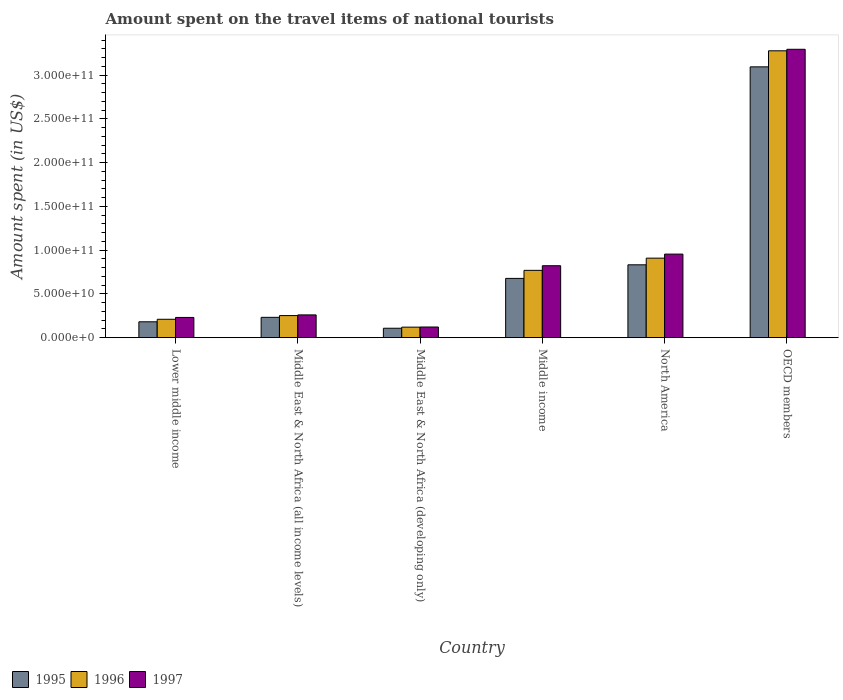How many groups of bars are there?
Give a very brief answer. 6. How many bars are there on the 3rd tick from the left?
Offer a very short reply. 3. What is the label of the 4th group of bars from the left?
Give a very brief answer. Middle income. What is the amount spent on the travel items of national tourists in 1997 in North America?
Ensure brevity in your answer.  9.55e+1. Across all countries, what is the maximum amount spent on the travel items of national tourists in 1997?
Keep it short and to the point. 3.29e+11. Across all countries, what is the minimum amount spent on the travel items of national tourists in 1996?
Offer a terse response. 1.20e+1. In which country was the amount spent on the travel items of national tourists in 1996 minimum?
Make the answer very short. Middle East & North Africa (developing only). What is the total amount spent on the travel items of national tourists in 1997 in the graph?
Your answer should be compact. 5.68e+11. What is the difference between the amount spent on the travel items of national tourists in 1996 in Lower middle income and that in Middle East & North Africa (developing only)?
Your answer should be very brief. 9.01e+09. What is the difference between the amount spent on the travel items of national tourists in 1995 in Lower middle income and the amount spent on the travel items of national tourists in 1996 in Middle East & North Africa (developing only)?
Ensure brevity in your answer.  6.13e+09. What is the average amount spent on the travel items of national tourists in 1995 per country?
Your answer should be very brief. 8.54e+1. What is the difference between the amount spent on the travel items of national tourists of/in 1995 and amount spent on the travel items of national tourists of/in 1996 in Middle East & North Africa (all income levels)?
Give a very brief answer. -1.99e+09. In how many countries, is the amount spent on the travel items of national tourists in 1995 greater than 130000000000 US$?
Offer a very short reply. 1. What is the ratio of the amount spent on the travel items of national tourists in 1995 in Middle East & North Africa (all income levels) to that in Middle income?
Offer a terse response. 0.34. Is the amount spent on the travel items of national tourists in 1997 in Lower middle income less than that in Middle East & North Africa (all income levels)?
Keep it short and to the point. Yes. Is the difference between the amount spent on the travel items of national tourists in 1995 in Middle East & North Africa (all income levels) and North America greater than the difference between the amount spent on the travel items of national tourists in 1996 in Middle East & North Africa (all income levels) and North America?
Your response must be concise. Yes. What is the difference between the highest and the second highest amount spent on the travel items of national tourists in 1996?
Your response must be concise. 2.51e+11. What is the difference between the highest and the lowest amount spent on the travel items of national tourists in 1996?
Your answer should be very brief. 3.16e+11. Is the sum of the amount spent on the travel items of national tourists in 1995 in Middle East & North Africa (all income levels) and OECD members greater than the maximum amount spent on the travel items of national tourists in 1996 across all countries?
Your answer should be compact. Yes. What does the 3rd bar from the left in OECD members represents?
Offer a terse response. 1997. What does the 3rd bar from the right in North America represents?
Your response must be concise. 1995. Are the values on the major ticks of Y-axis written in scientific E-notation?
Your response must be concise. Yes. What is the title of the graph?
Offer a terse response. Amount spent on the travel items of national tourists. Does "1978" appear as one of the legend labels in the graph?
Your response must be concise. No. What is the label or title of the X-axis?
Offer a very short reply. Country. What is the label or title of the Y-axis?
Your response must be concise. Amount spent (in US$). What is the Amount spent (in US$) of 1995 in Lower middle income?
Provide a short and direct response. 1.81e+1. What is the Amount spent (in US$) in 1996 in Lower middle income?
Your response must be concise. 2.10e+1. What is the Amount spent (in US$) in 1997 in Lower middle income?
Ensure brevity in your answer.  2.31e+1. What is the Amount spent (in US$) of 1995 in Middle East & North Africa (all income levels)?
Your response must be concise. 2.32e+1. What is the Amount spent (in US$) in 1996 in Middle East & North Africa (all income levels)?
Keep it short and to the point. 2.52e+1. What is the Amount spent (in US$) of 1997 in Middle East & North Africa (all income levels)?
Your answer should be very brief. 2.60e+1. What is the Amount spent (in US$) of 1995 in Middle East & North Africa (developing only)?
Make the answer very short. 1.08e+1. What is the Amount spent (in US$) in 1996 in Middle East & North Africa (developing only)?
Ensure brevity in your answer.  1.20e+1. What is the Amount spent (in US$) of 1997 in Middle East & North Africa (developing only)?
Your response must be concise. 1.22e+1. What is the Amount spent (in US$) of 1995 in Middle income?
Provide a short and direct response. 6.77e+1. What is the Amount spent (in US$) of 1996 in Middle income?
Your response must be concise. 7.69e+1. What is the Amount spent (in US$) in 1997 in Middle income?
Your response must be concise. 8.22e+1. What is the Amount spent (in US$) in 1995 in North America?
Give a very brief answer. 8.32e+1. What is the Amount spent (in US$) in 1996 in North America?
Keep it short and to the point. 9.09e+1. What is the Amount spent (in US$) of 1997 in North America?
Offer a terse response. 9.55e+1. What is the Amount spent (in US$) in 1995 in OECD members?
Your answer should be very brief. 3.09e+11. What is the Amount spent (in US$) in 1996 in OECD members?
Make the answer very short. 3.28e+11. What is the Amount spent (in US$) in 1997 in OECD members?
Offer a very short reply. 3.29e+11. Across all countries, what is the maximum Amount spent (in US$) in 1995?
Your answer should be compact. 3.09e+11. Across all countries, what is the maximum Amount spent (in US$) in 1996?
Keep it short and to the point. 3.28e+11. Across all countries, what is the maximum Amount spent (in US$) in 1997?
Your answer should be compact. 3.29e+11. Across all countries, what is the minimum Amount spent (in US$) in 1995?
Your answer should be very brief. 1.08e+1. Across all countries, what is the minimum Amount spent (in US$) in 1996?
Your answer should be compact. 1.20e+1. Across all countries, what is the minimum Amount spent (in US$) of 1997?
Keep it short and to the point. 1.22e+1. What is the total Amount spent (in US$) of 1995 in the graph?
Ensure brevity in your answer.  5.13e+11. What is the total Amount spent (in US$) of 1996 in the graph?
Offer a very short reply. 5.54e+11. What is the total Amount spent (in US$) of 1997 in the graph?
Keep it short and to the point. 5.68e+11. What is the difference between the Amount spent (in US$) of 1995 in Lower middle income and that in Middle East & North Africa (all income levels)?
Give a very brief answer. -5.09e+09. What is the difference between the Amount spent (in US$) in 1996 in Lower middle income and that in Middle East & North Africa (all income levels)?
Keep it short and to the point. -4.20e+09. What is the difference between the Amount spent (in US$) of 1997 in Lower middle income and that in Middle East & North Africa (all income levels)?
Offer a terse response. -2.91e+09. What is the difference between the Amount spent (in US$) of 1995 in Lower middle income and that in Middle East & North Africa (developing only)?
Your answer should be compact. 7.36e+09. What is the difference between the Amount spent (in US$) in 1996 in Lower middle income and that in Middle East & North Africa (developing only)?
Provide a succinct answer. 9.01e+09. What is the difference between the Amount spent (in US$) of 1997 in Lower middle income and that in Middle East & North Africa (developing only)?
Ensure brevity in your answer.  1.09e+1. What is the difference between the Amount spent (in US$) of 1995 in Lower middle income and that in Middle income?
Offer a terse response. -4.96e+1. What is the difference between the Amount spent (in US$) of 1996 in Lower middle income and that in Middle income?
Your answer should be very brief. -5.59e+1. What is the difference between the Amount spent (in US$) of 1997 in Lower middle income and that in Middle income?
Offer a terse response. -5.91e+1. What is the difference between the Amount spent (in US$) in 1995 in Lower middle income and that in North America?
Offer a terse response. -6.51e+1. What is the difference between the Amount spent (in US$) of 1996 in Lower middle income and that in North America?
Offer a very short reply. -6.98e+1. What is the difference between the Amount spent (in US$) in 1997 in Lower middle income and that in North America?
Make the answer very short. -7.24e+1. What is the difference between the Amount spent (in US$) of 1995 in Lower middle income and that in OECD members?
Give a very brief answer. -2.91e+11. What is the difference between the Amount spent (in US$) in 1996 in Lower middle income and that in OECD members?
Make the answer very short. -3.07e+11. What is the difference between the Amount spent (in US$) in 1997 in Lower middle income and that in OECD members?
Keep it short and to the point. -3.06e+11. What is the difference between the Amount spent (in US$) of 1995 in Middle East & North Africa (all income levels) and that in Middle East & North Africa (developing only)?
Your response must be concise. 1.25e+1. What is the difference between the Amount spent (in US$) in 1996 in Middle East & North Africa (all income levels) and that in Middle East & North Africa (developing only)?
Make the answer very short. 1.32e+1. What is the difference between the Amount spent (in US$) of 1997 in Middle East & North Africa (all income levels) and that in Middle East & North Africa (developing only)?
Ensure brevity in your answer.  1.38e+1. What is the difference between the Amount spent (in US$) in 1995 in Middle East & North Africa (all income levels) and that in Middle income?
Ensure brevity in your answer.  -4.45e+1. What is the difference between the Amount spent (in US$) of 1996 in Middle East & North Africa (all income levels) and that in Middle income?
Your answer should be very brief. -5.17e+1. What is the difference between the Amount spent (in US$) of 1997 in Middle East & North Africa (all income levels) and that in Middle income?
Provide a short and direct response. -5.62e+1. What is the difference between the Amount spent (in US$) of 1995 in Middle East & North Africa (all income levels) and that in North America?
Offer a very short reply. -6.00e+1. What is the difference between the Amount spent (in US$) in 1996 in Middle East & North Africa (all income levels) and that in North America?
Provide a short and direct response. -6.56e+1. What is the difference between the Amount spent (in US$) in 1997 in Middle East & North Africa (all income levels) and that in North America?
Provide a succinct answer. -6.95e+1. What is the difference between the Amount spent (in US$) of 1995 in Middle East & North Africa (all income levels) and that in OECD members?
Offer a very short reply. -2.86e+11. What is the difference between the Amount spent (in US$) of 1996 in Middle East & North Africa (all income levels) and that in OECD members?
Ensure brevity in your answer.  -3.03e+11. What is the difference between the Amount spent (in US$) of 1997 in Middle East & North Africa (all income levels) and that in OECD members?
Provide a succinct answer. -3.03e+11. What is the difference between the Amount spent (in US$) in 1995 in Middle East & North Africa (developing only) and that in Middle income?
Make the answer very short. -5.69e+1. What is the difference between the Amount spent (in US$) in 1996 in Middle East & North Africa (developing only) and that in Middle income?
Your response must be concise. -6.49e+1. What is the difference between the Amount spent (in US$) in 1997 in Middle East & North Africa (developing only) and that in Middle income?
Make the answer very short. -7.00e+1. What is the difference between the Amount spent (in US$) in 1995 in Middle East & North Africa (developing only) and that in North America?
Keep it short and to the point. -7.25e+1. What is the difference between the Amount spent (in US$) of 1996 in Middle East & North Africa (developing only) and that in North America?
Provide a short and direct response. -7.88e+1. What is the difference between the Amount spent (in US$) of 1997 in Middle East & North Africa (developing only) and that in North America?
Offer a terse response. -8.33e+1. What is the difference between the Amount spent (in US$) in 1995 in Middle East & North Africa (developing only) and that in OECD members?
Keep it short and to the point. -2.99e+11. What is the difference between the Amount spent (in US$) of 1996 in Middle East & North Africa (developing only) and that in OECD members?
Provide a short and direct response. -3.16e+11. What is the difference between the Amount spent (in US$) in 1997 in Middle East & North Africa (developing only) and that in OECD members?
Offer a terse response. -3.17e+11. What is the difference between the Amount spent (in US$) of 1995 in Middle income and that in North America?
Your answer should be very brief. -1.55e+1. What is the difference between the Amount spent (in US$) in 1996 in Middle income and that in North America?
Provide a short and direct response. -1.39e+1. What is the difference between the Amount spent (in US$) in 1997 in Middle income and that in North America?
Provide a succinct answer. -1.33e+1. What is the difference between the Amount spent (in US$) in 1995 in Middle income and that in OECD members?
Ensure brevity in your answer.  -2.42e+11. What is the difference between the Amount spent (in US$) in 1996 in Middle income and that in OECD members?
Your answer should be compact. -2.51e+11. What is the difference between the Amount spent (in US$) of 1997 in Middle income and that in OECD members?
Give a very brief answer. -2.47e+11. What is the difference between the Amount spent (in US$) in 1995 in North America and that in OECD members?
Offer a very short reply. -2.26e+11. What is the difference between the Amount spent (in US$) of 1996 in North America and that in OECD members?
Your answer should be very brief. -2.37e+11. What is the difference between the Amount spent (in US$) of 1997 in North America and that in OECD members?
Offer a terse response. -2.34e+11. What is the difference between the Amount spent (in US$) in 1995 in Lower middle income and the Amount spent (in US$) in 1996 in Middle East & North Africa (all income levels)?
Provide a short and direct response. -7.08e+09. What is the difference between the Amount spent (in US$) in 1995 in Lower middle income and the Amount spent (in US$) in 1997 in Middle East & North Africa (all income levels)?
Make the answer very short. -7.88e+09. What is the difference between the Amount spent (in US$) of 1996 in Lower middle income and the Amount spent (in US$) of 1997 in Middle East & North Africa (all income levels)?
Ensure brevity in your answer.  -5.00e+09. What is the difference between the Amount spent (in US$) of 1995 in Lower middle income and the Amount spent (in US$) of 1996 in Middle East & North Africa (developing only)?
Your answer should be compact. 6.13e+09. What is the difference between the Amount spent (in US$) in 1995 in Lower middle income and the Amount spent (in US$) in 1997 in Middle East & North Africa (developing only)?
Provide a short and direct response. 5.97e+09. What is the difference between the Amount spent (in US$) in 1996 in Lower middle income and the Amount spent (in US$) in 1997 in Middle East & North Africa (developing only)?
Keep it short and to the point. 8.84e+09. What is the difference between the Amount spent (in US$) in 1995 in Lower middle income and the Amount spent (in US$) in 1996 in Middle income?
Give a very brief answer. -5.88e+1. What is the difference between the Amount spent (in US$) of 1995 in Lower middle income and the Amount spent (in US$) of 1997 in Middle income?
Your response must be concise. -6.41e+1. What is the difference between the Amount spent (in US$) of 1996 in Lower middle income and the Amount spent (in US$) of 1997 in Middle income?
Make the answer very short. -6.12e+1. What is the difference between the Amount spent (in US$) of 1995 in Lower middle income and the Amount spent (in US$) of 1996 in North America?
Offer a very short reply. -7.27e+1. What is the difference between the Amount spent (in US$) in 1995 in Lower middle income and the Amount spent (in US$) in 1997 in North America?
Make the answer very short. -7.73e+1. What is the difference between the Amount spent (in US$) in 1996 in Lower middle income and the Amount spent (in US$) in 1997 in North America?
Your answer should be very brief. -7.45e+1. What is the difference between the Amount spent (in US$) of 1995 in Lower middle income and the Amount spent (in US$) of 1996 in OECD members?
Give a very brief answer. -3.10e+11. What is the difference between the Amount spent (in US$) of 1995 in Lower middle income and the Amount spent (in US$) of 1997 in OECD members?
Your response must be concise. -3.11e+11. What is the difference between the Amount spent (in US$) of 1996 in Lower middle income and the Amount spent (in US$) of 1997 in OECD members?
Provide a short and direct response. -3.08e+11. What is the difference between the Amount spent (in US$) of 1995 in Middle East & North Africa (all income levels) and the Amount spent (in US$) of 1996 in Middle East & North Africa (developing only)?
Your response must be concise. 1.12e+1. What is the difference between the Amount spent (in US$) in 1995 in Middle East & North Africa (all income levels) and the Amount spent (in US$) in 1997 in Middle East & North Africa (developing only)?
Make the answer very short. 1.11e+1. What is the difference between the Amount spent (in US$) in 1996 in Middle East & North Africa (all income levels) and the Amount spent (in US$) in 1997 in Middle East & North Africa (developing only)?
Your response must be concise. 1.30e+1. What is the difference between the Amount spent (in US$) in 1995 in Middle East & North Africa (all income levels) and the Amount spent (in US$) in 1996 in Middle income?
Offer a very short reply. -5.37e+1. What is the difference between the Amount spent (in US$) of 1995 in Middle East & North Africa (all income levels) and the Amount spent (in US$) of 1997 in Middle income?
Keep it short and to the point. -5.90e+1. What is the difference between the Amount spent (in US$) in 1996 in Middle East & North Africa (all income levels) and the Amount spent (in US$) in 1997 in Middle income?
Offer a very short reply. -5.70e+1. What is the difference between the Amount spent (in US$) of 1995 in Middle East & North Africa (all income levels) and the Amount spent (in US$) of 1996 in North America?
Offer a very short reply. -6.76e+1. What is the difference between the Amount spent (in US$) of 1995 in Middle East & North Africa (all income levels) and the Amount spent (in US$) of 1997 in North America?
Keep it short and to the point. -7.22e+1. What is the difference between the Amount spent (in US$) of 1996 in Middle East & North Africa (all income levels) and the Amount spent (in US$) of 1997 in North America?
Your answer should be very brief. -7.03e+1. What is the difference between the Amount spent (in US$) in 1995 in Middle East & North Africa (all income levels) and the Amount spent (in US$) in 1996 in OECD members?
Give a very brief answer. -3.05e+11. What is the difference between the Amount spent (in US$) in 1995 in Middle East & North Africa (all income levels) and the Amount spent (in US$) in 1997 in OECD members?
Your answer should be compact. -3.06e+11. What is the difference between the Amount spent (in US$) in 1996 in Middle East & North Africa (all income levels) and the Amount spent (in US$) in 1997 in OECD members?
Offer a terse response. -3.04e+11. What is the difference between the Amount spent (in US$) in 1995 in Middle East & North Africa (developing only) and the Amount spent (in US$) in 1996 in Middle income?
Provide a succinct answer. -6.61e+1. What is the difference between the Amount spent (in US$) in 1995 in Middle East & North Africa (developing only) and the Amount spent (in US$) in 1997 in Middle income?
Provide a short and direct response. -7.14e+1. What is the difference between the Amount spent (in US$) in 1996 in Middle East & North Africa (developing only) and the Amount spent (in US$) in 1997 in Middle income?
Your answer should be very brief. -7.02e+1. What is the difference between the Amount spent (in US$) in 1995 in Middle East & North Africa (developing only) and the Amount spent (in US$) in 1996 in North America?
Ensure brevity in your answer.  -8.01e+1. What is the difference between the Amount spent (in US$) of 1995 in Middle East & North Africa (developing only) and the Amount spent (in US$) of 1997 in North America?
Give a very brief answer. -8.47e+1. What is the difference between the Amount spent (in US$) of 1996 in Middle East & North Africa (developing only) and the Amount spent (in US$) of 1997 in North America?
Offer a very short reply. -8.35e+1. What is the difference between the Amount spent (in US$) of 1995 in Middle East & North Africa (developing only) and the Amount spent (in US$) of 1996 in OECD members?
Make the answer very short. -3.17e+11. What is the difference between the Amount spent (in US$) of 1995 in Middle East & North Africa (developing only) and the Amount spent (in US$) of 1997 in OECD members?
Offer a very short reply. -3.19e+11. What is the difference between the Amount spent (in US$) in 1996 in Middle East & North Africa (developing only) and the Amount spent (in US$) in 1997 in OECD members?
Offer a terse response. -3.17e+11. What is the difference between the Amount spent (in US$) in 1995 in Middle income and the Amount spent (in US$) in 1996 in North America?
Your answer should be very brief. -2.31e+1. What is the difference between the Amount spent (in US$) of 1995 in Middle income and the Amount spent (in US$) of 1997 in North America?
Offer a terse response. -2.78e+1. What is the difference between the Amount spent (in US$) in 1996 in Middle income and the Amount spent (in US$) in 1997 in North America?
Give a very brief answer. -1.86e+1. What is the difference between the Amount spent (in US$) in 1995 in Middle income and the Amount spent (in US$) in 1996 in OECD members?
Ensure brevity in your answer.  -2.60e+11. What is the difference between the Amount spent (in US$) of 1995 in Middle income and the Amount spent (in US$) of 1997 in OECD members?
Your response must be concise. -2.62e+11. What is the difference between the Amount spent (in US$) in 1996 in Middle income and the Amount spent (in US$) in 1997 in OECD members?
Your answer should be very brief. -2.53e+11. What is the difference between the Amount spent (in US$) in 1995 in North America and the Amount spent (in US$) in 1996 in OECD members?
Keep it short and to the point. -2.45e+11. What is the difference between the Amount spent (in US$) of 1995 in North America and the Amount spent (in US$) of 1997 in OECD members?
Your answer should be compact. -2.46e+11. What is the difference between the Amount spent (in US$) of 1996 in North America and the Amount spent (in US$) of 1997 in OECD members?
Offer a very short reply. -2.39e+11. What is the average Amount spent (in US$) of 1995 per country?
Ensure brevity in your answer.  8.54e+1. What is the average Amount spent (in US$) of 1996 per country?
Your answer should be compact. 9.23e+1. What is the average Amount spent (in US$) of 1997 per country?
Provide a short and direct response. 9.47e+1. What is the difference between the Amount spent (in US$) in 1995 and Amount spent (in US$) in 1996 in Lower middle income?
Provide a short and direct response. -2.88e+09. What is the difference between the Amount spent (in US$) of 1995 and Amount spent (in US$) of 1997 in Lower middle income?
Your answer should be very brief. -4.97e+09. What is the difference between the Amount spent (in US$) in 1996 and Amount spent (in US$) in 1997 in Lower middle income?
Provide a short and direct response. -2.09e+09. What is the difference between the Amount spent (in US$) of 1995 and Amount spent (in US$) of 1996 in Middle East & North Africa (all income levels)?
Your response must be concise. -1.99e+09. What is the difference between the Amount spent (in US$) of 1995 and Amount spent (in US$) of 1997 in Middle East & North Africa (all income levels)?
Provide a short and direct response. -2.79e+09. What is the difference between the Amount spent (in US$) in 1996 and Amount spent (in US$) in 1997 in Middle East & North Africa (all income levels)?
Provide a succinct answer. -7.97e+08. What is the difference between the Amount spent (in US$) of 1995 and Amount spent (in US$) of 1996 in Middle East & North Africa (developing only)?
Give a very brief answer. -1.24e+09. What is the difference between the Amount spent (in US$) of 1995 and Amount spent (in US$) of 1997 in Middle East & North Africa (developing only)?
Your response must be concise. -1.40e+09. What is the difference between the Amount spent (in US$) in 1996 and Amount spent (in US$) in 1997 in Middle East & North Africa (developing only)?
Ensure brevity in your answer.  -1.61e+08. What is the difference between the Amount spent (in US$) of 1995 and Amount spent (in US$) of 1996 in Middle income?
Offer a terse response. -9.19e+09. What is the difference between the Amount spent (in US$) in 1995 and Amount spent (in US$) in 1997 in Middle income?
Make the answer very short. -1.45e+1. What is the difference between the Amount spent (in US$) in 1996 and Amount spent (in US$) in 1997 in Middle income?
Provide a short and direct response. -5.28e+09. What is the difference between the Amount spent (in US$) in 1995 and Amount spent (in US$) in 1996 in North America?
Provide a short and direct response. -7.61e+09. What is the difference between the Amount spent (in US$) in 1995 and Amount spent (in US$) in 1997 in North America?
Your answer should be very brief. -1.22e+1. What is the difference between the Amount spent (in US$) in 1996 and Amount spent (in US$) in 1997 in North America?
Make the answer very short. -4.62e+09. What is the difference between the Amount spent (in US$) of 1995 and Amount spent (in US$) of 1996 in OECD members?
Keep it short and to the point. -1.83e+1. What is the difference between the Amount spent (in US$) in 1995 and Amount spent (in US$) in 1997 in OECD members?
Keep it short and to the point. -2.01e+1. What is the difference between the Amount spent (in US$) in 1996 and Amount spent (in US$) in 1997 in OECD members?
Ensure brevity in your answer.  -1.72e+09. What is the ratio of the Amount spent (in US$) in 1995 in Lower middle income to that in Middle East & North Africa (all income levels)?
Your response must be concise. 0.78. What is the ratio of the Amount spent (in US$) in 1996 in Lower middle income to that in Middle East & North Africa (all income levels)?
Give a very brief answer. 0.83. What is the ratio of the Amount spent (in US$) in 1997 in Lower middle income to that in Middle East & North Africa (all income levels)?
Offer a very short reply. 0.89. What is the ratio of the Amount spent (in US$) in 1995 in Lower middle income to that in Middle East & North Africa (developing only)?
Provide a short and direct response. 1.68. What is the ratio of the Amount spent (in US$) of 1996 in Lower middle income to that in Middle East & North Africa (developing only)?
Your answer should be compact. 1.75. What is the ratio of the Amount spent (in US$) of 1997 in Lower middle income to that in Middle East & North Africa (developing only)?
Offer a very short reply. 1.9. What is the ratio of the Amount spent (in US$) in 1995 in Lower middle income to that in Middle income?
Provide a short and direct response. 0.27. What is the ratio of the Amount spent (in US$) of 1996 in Lower middle income to that in Middle income?
Provide a succinct answer. 0.27. What is the ratio of the Amount spent (in US$) of 1997 in Lower middle income to that in Middle income?
Offer a terse response. 0.28. What is the ratio of the Amount spent (in US$) in 1995 in Lower middle income to that in North America?
Your answer should be compact. 0.22. What is the ratio of the Amount spent (in US$) of 1996 in Lower middle income to that in North America?
Make the answer very short. 0.23. What is the ratio of the Amount spent (in US$) of 1997 in Lower middle income to that in North America?
Provide a succinct answer. 0.24. What is the ratio of the Amount spent (in US$) of 1995 in Lower middle income to that in OECD members?
Your answer should be very brief. 0.06. What is the ratio of the Amount spent (in US$) in 1996 in Lower middle income to that in OECD members?
Keep it short and to the point. 0.06. What is the ratio of the Amount spent (in US$) of 1997 in Lower middle income to that in OECD members?
Make the answer very short. 0.07. What is the ratio of the Amount spent (in US$) in 1995 in Middle East & North Africa (all income levels) to that in Middle East & North Africa (developing only)?
Keep it short and to the point. 2.16. What is the ratio of the Amount spent (in US$) in 1996 in Middle East & North Africa (all income levels) to that in Middle East & North Africa (developing only)?
Offer a terse response. 2.1. What is the ratio of the Amount spent (in US$) of 1997 in Middle East & North Africa (all income levels) to that in Middle East & North Africa (developing only)?
Keep it short and to the point. 2.14. What is the ratio of the Amount spent (in US$) of 1995 in Middle East & North Africa (all income levels) to that in Middle income?
Provide a succinct answer. 0.34. What is the ratio of the Amount spent (in US$) of 1996 in Middle East & North Africa (all income levels) to that in Middle income?
Give a very brief answer. 0.33. What is the ratio of the Amount spent (in US$) in 1997 in Middle East & North Africa (all income levels) to that in Middle income?
Provide a succinct answer. 0.32. What is the ratio of the Amount spent (in US$) in 1995 in Middle East & North Africa (all income levels) to that in North America?
Your response must be concise. 0.28. What is the ratio of the Amount spent (in US$) of 1996 in Middle East & North Africa (all income levels) to that in North America?
Offer a terse response. 0.28. What is the ratio of the Amount spent (in US$) of 1997 in Middle East & North Africa (all income levels) to that in North America?
Give a very brief answer. 0.27. What is the ratio of the Amount spent (in US$) of 1995 in Middle East & North Africa (all income levels) to that in OECD members?
Provide a short and direct response. 0.08. What is the ratio of the Amount spent (in US$) in 1996 in Middle East & North Africa (all income levels) to that in OECD members?
Keep it short and to the point. 0.08. What is the ratio of the Amount spent (in US$) of 1997 in Middle East & North Africa (all income levels) to that in OECD members?
Your answer should be compact. 0.08. What is the ratio of the Amount spent (in US$) of 1995 in Middle East & North Africa (developing only) to that in Middle income?
Give a very brief answer. 0.16. What is the ratio of the Amount spent (in US$) in 1996 in Middle East & North Africa (developing only) to that in Middle income?
Provide a succinct answer. 0.16. What is the ratio of the Amount spent (in US$) in 1997 in Middle East & North Africa (developing only) to that in Middle income?
Offer a terse response. 0.15. What is the ratio of the Amount spent (in US$) of 1995 in Middle East & North Africa (developing only) to that in North America?
Make the answer very short. 0.13. What is the ratio of the Amount spent (in US$) in 1996 in Middle East & North Africa (developing only) to that in North America?
Your answer should be very brief. 0.13. What is the ratio of the Amount spent (in US$) in 1997 in Middle East & North Africa (developing only) to that in North America?
Offer a terse response. 0.13. What is the ratio of the Amount spent (in US$) in 1995 in Middle East & North Africa (developing only) to that in OECD members?
Provide a succinct answer. 0.03. What is the ratio of the Amount spent (in US$) of 1996 in Middle East & North Africa (developing only) to that in OECD members?
Make the answer very short. 0.04. What is the ratio of the Amount spent (in US$) in 1997 in Middle East & North Africa (developing only) to that in OECD members?
Provide a succinct answer. 0.04. What is the ratio of the Amount spent (in US$) in 1995 in Middle income to that in North America?
Your response must be concise. 0.81. What is the ratio of the Amount spent (in US$) in 1996 in Middle income to that in North America?
Ensure brevity in your answer.  0.85. What is the ratio of the Amount spent (in US$) of 1997 in Middle income to that in North America?
Offer a very short reply. 0.86. What is the ratio of the Amount spent (in US$) in 1995 in Middle income to that in OECD members?
Your response must be concise. 0.22. What is the ratio of the Amount spent (in US$) of 1996 in Middle income to that in OECD members?
Give a very brief answer. 0.23. What is the ratio of the Amount spent (in US$) of 1997 in Middle income to that in OECD members?
Your answer should be very brief. 0.25. What is the ratio of the Amount spent (in US$) in 1995 in North America to that in OECD members?
Ensure brevity in your answer.  0.27. What is the ratio of the Amount spent (in US$) in 1996 in North America to that in OECD members?
Your response must be concise. 0.28. What is the ratio of the Amount spent (in US$) in 1997 in North America to that in OECD members?
Your answer should be very brief. 0.29. What is the difference between the highest and the second highest Amount spent (in US$) in 1995?
Keep it short and to the point. 2.26e+11. What is the difference between the highest and the second highest Amount spent (in US$) of 1996?
Offer a very short reply. 2.37e+11. What is the difference between the highest and the second highest Amount spent (in US$) in 1997?
Provide a short and direct response. 2.34e+11. What is the difference between the highest and the lowest Amount spent (in US$) in 1995?
Offer a terse response. 2.99e+11. What is the difference between the highest and the lowest Amount spent (in US$) of 1996?
Your answer should be compact. 3.16e+11. What is the difference between the highest and the lowest Amount spent (in US$) of 1997?
Your response must be concise. 3.17e+11. 